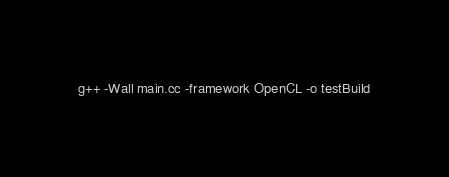<code> <loc_0><loc_0><loc_500><loc_500><_Bash_>g++ -Wall main.cc -framework OpenCL -o testBuild
</code> 